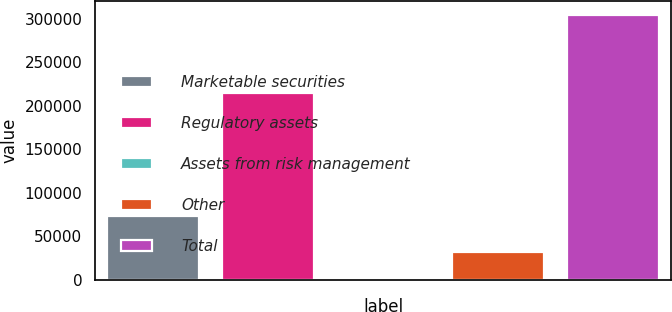Convert chart to OTSL. <chart><loc_0><loc_0><loc_500><loc_500><bar_chart><fcel>Marketable securities<fcel>Regulatory assets<fcel>Assets from risk management<fcel>Other<fcel>Total<nl><fcel>72701<fcel>214890<fcel>1822<fcel>32141.7<fcel>305019<nl></chart> 